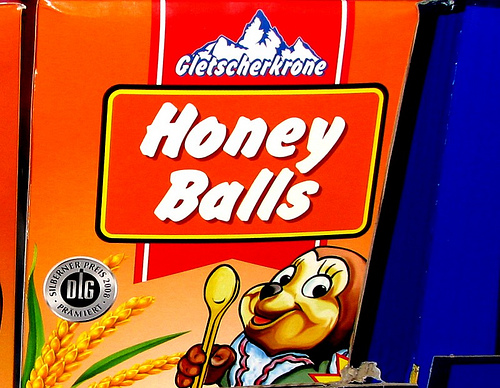<image>
Is the honey under the balls? No. The honey is not positioned under the balls. The vertical relationship between these objects is different. Where is the corn in relation to the chipmunk? Is it behind the chipmunk? Yes. From this viewpoint, the corn is positioned behind the chipmunk, with the chipmunk partially or fully occluding the corn. 